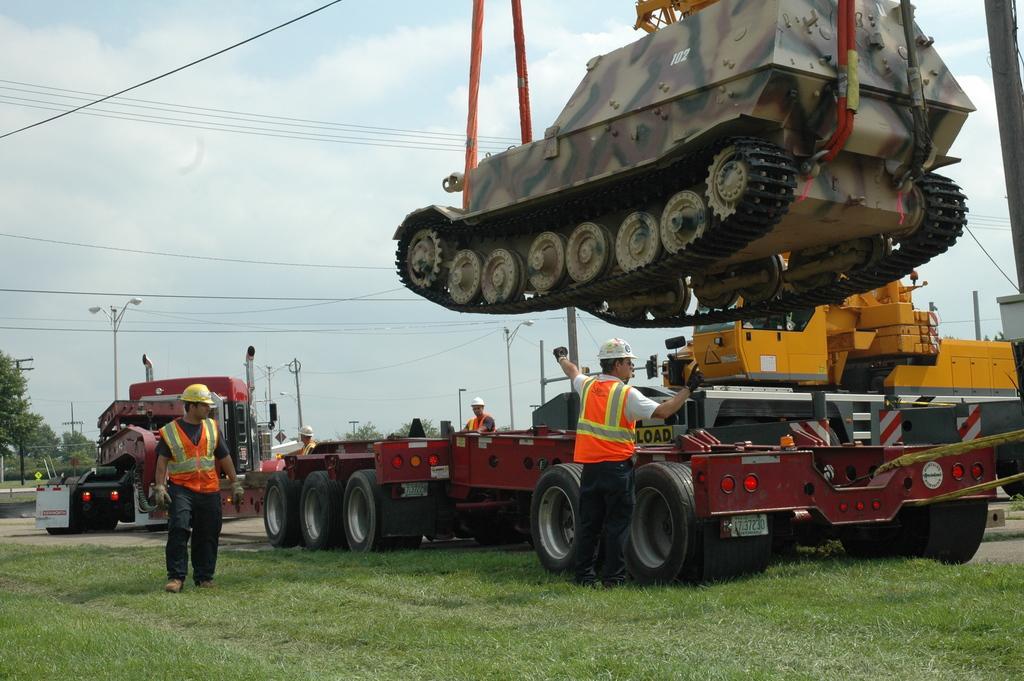How would you summarize this image in a sentence or two? In this image I can see grass, few vehicles, a tank, few people, number of poles, lights, wires, trees, clouds and the sky. Here I can see they all are wearing jackets and helmets. 